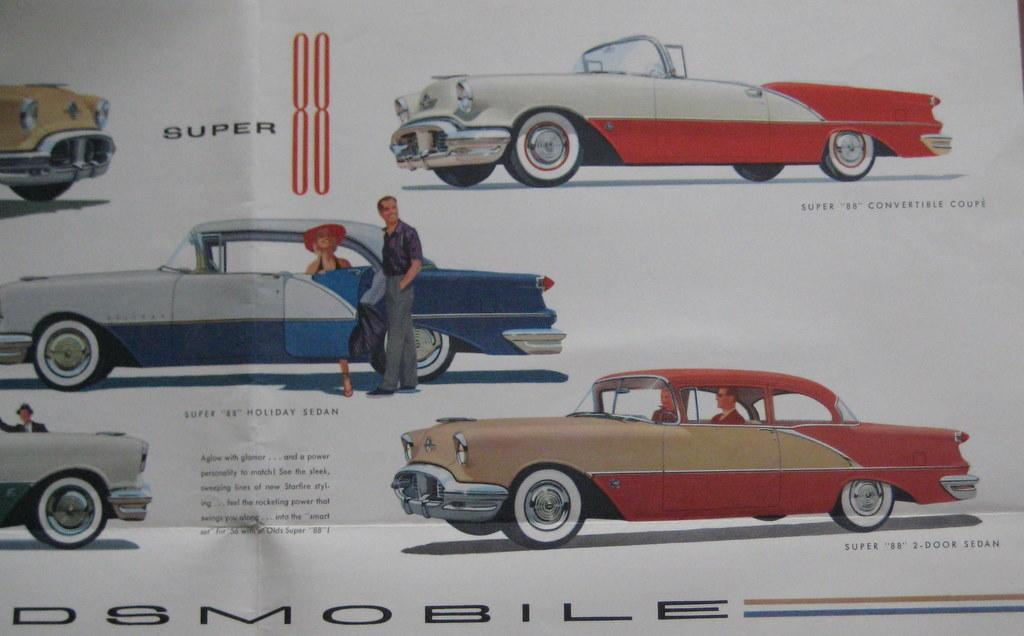What is featured on the poster in the image? The poster contains images of cars and people. What else can be found on the poster besides the images? There is text on the poster. What type of jam is being advertised on the poster? There is no jam being advertised on the poster; it contains images of cars and people, along with text. 